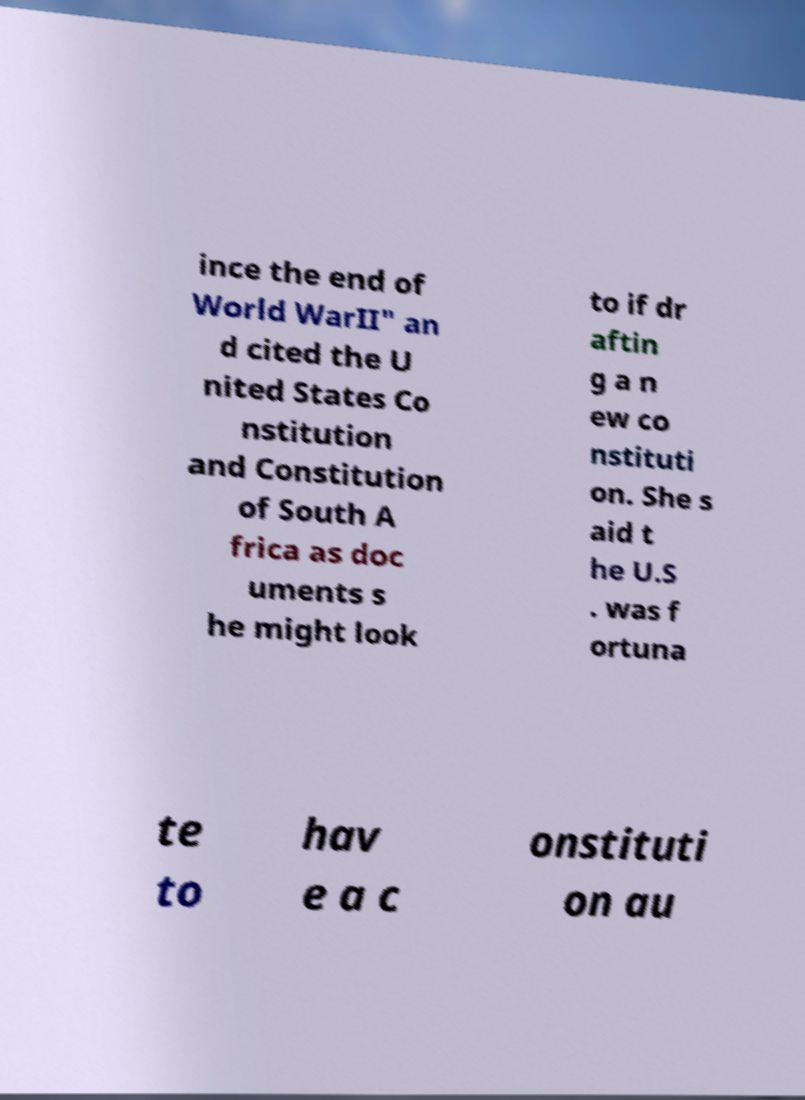Could you extract and type out the text from this image? ince the end of World WarII" an d cited the U nited States Co nstitution and Constitution of South A frica as doc uments s he might look to if dr aftin g a n ew co nstituti on. She s aid t he U.S . was f ortuna te to hav e a c onstituti on au 